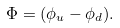Convert formula to latex. <formula><loc_0><loc_0><loc_500><loc_500>\Phi = ( \phi _ { u } - \phi _ { d } ) .</formula> 